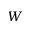Convert formula to latex. <formula><loc_0><loc_0><loc_500><loc_500>W</formula> 